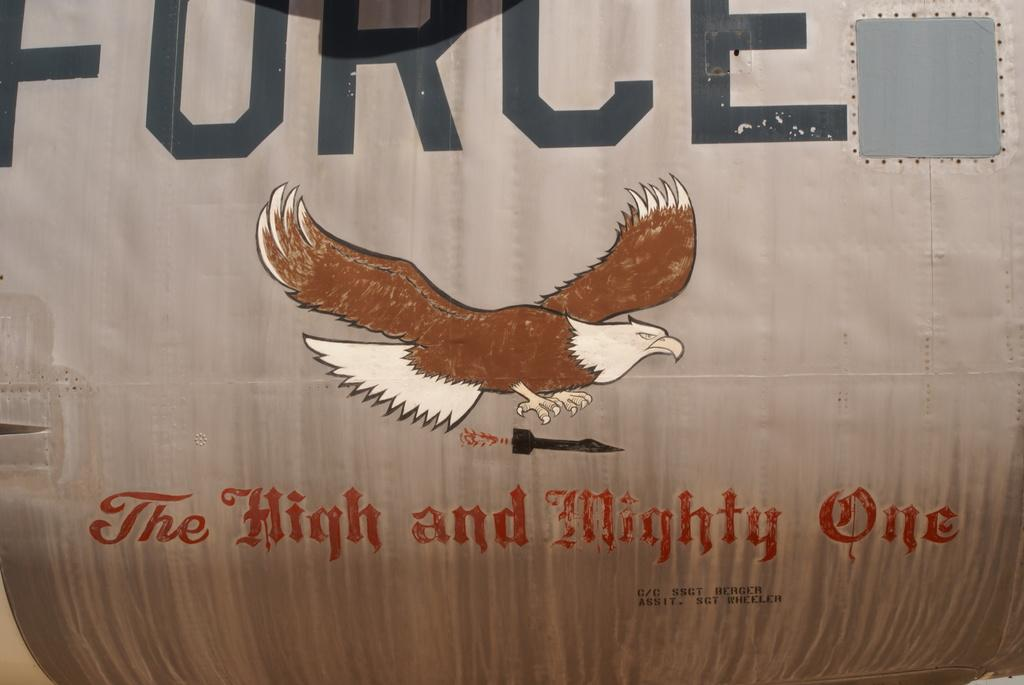What is depicted in the painting on the wall? There is a painting of an eagle on the wall. What is present above the eagle painting? There is text above the eagle painting. What is present below the eagle painting? There is text below the eagle painting. Can you tell me how many yaks are swimming in the lake depicted in the painting? There are no yaks or lakes depicted in the painting; it features an eagle. 